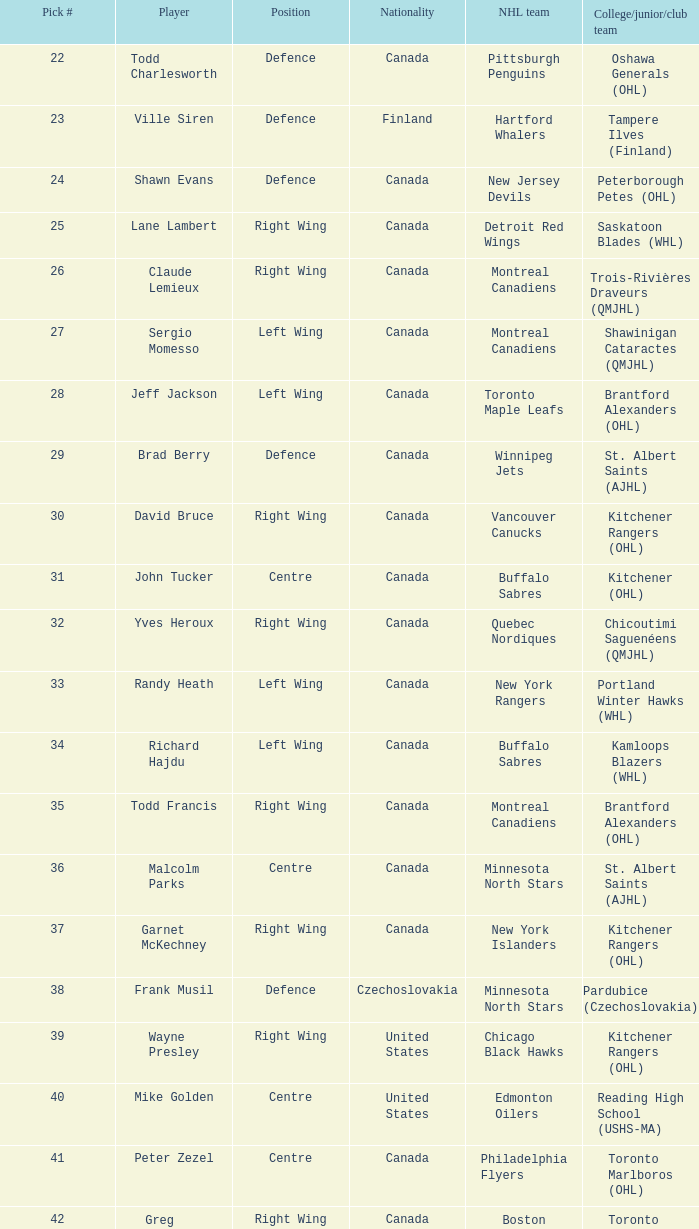What is the selection number when the nhl team is montreal canadiens and the college/junior/club team is trois-rivières draveurs (qmjhl)? 26.0. 